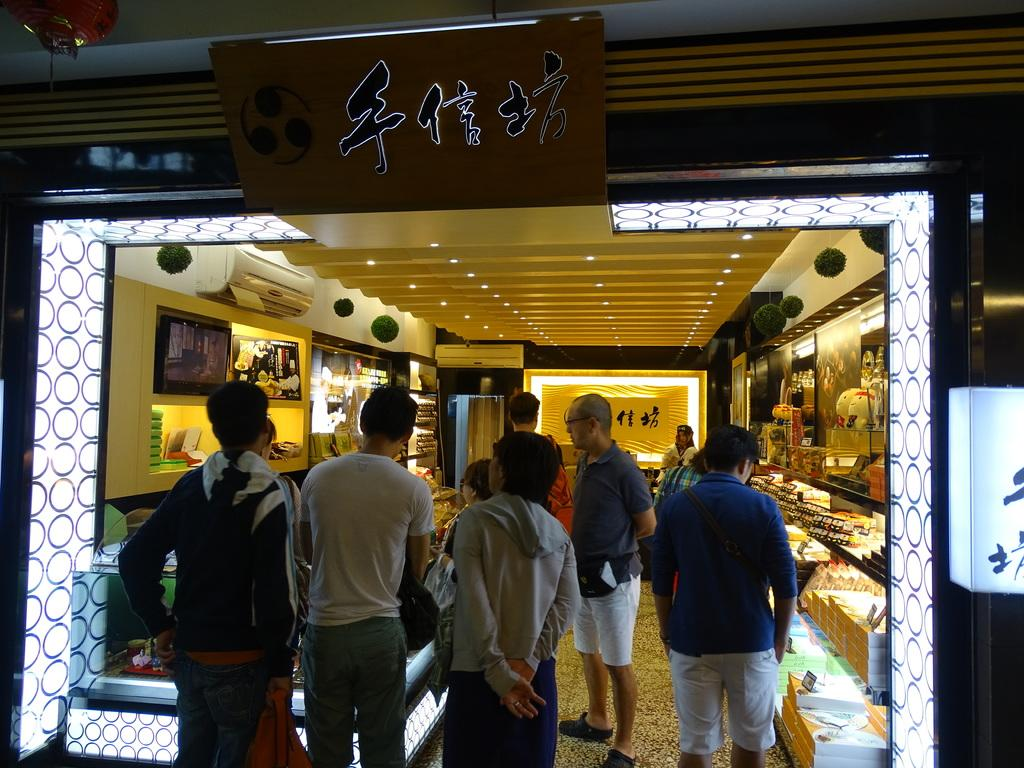What type of location is depicted in the image? The image shows the inside view of a store. Are there any specific features in the store? Yes, there is an air conditioner in the store. Can you describe the people in the store? There are people in the store, but their specific actions or characteristics are not mentioned in the facts. What type of objects can be seen in the store? Decorative objects and other objects are present in the store. What is the lighting situation in the store? Lights are visible in the store. What type of dinner is being served in the church in the image? There is no church or dinner present in the image; it shows the inside view of a store. 